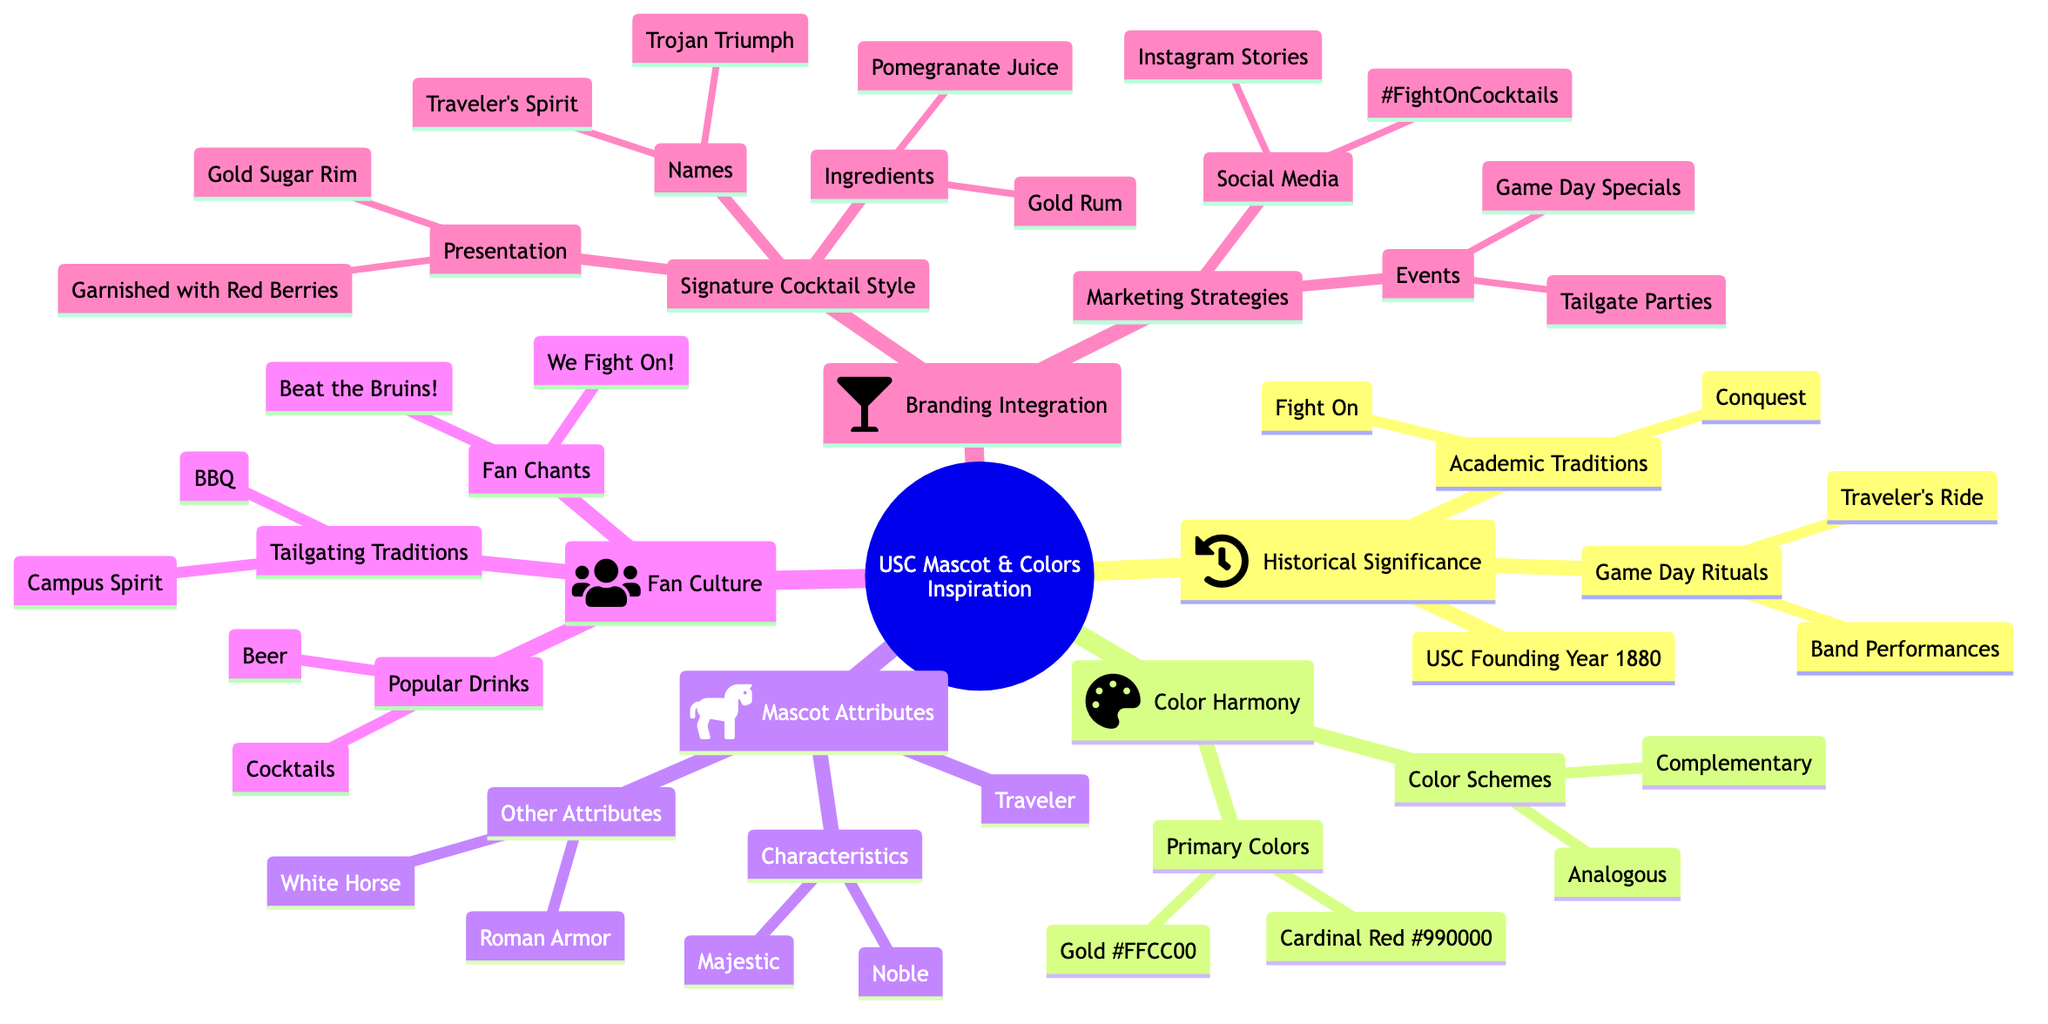What is the founding year of USC? The diagram states that the founding year of USC is 1880 under the Historical Significance section.
Answer: 1880 What are the signature cocktail names? In the Branding Integration section, the Names under Signature Cocktail Style lists "Traveler's Spirit" and "Trojan Triumph."
Answer: Traveler's Spirit, Trojan Triumph Which color is associated with the cardinal? The Color Harmony section shows that Cardinal Red is associated with the color code #990000.
Answer: Cardinal Red How many popular drinks are listed under Fan Culture? The Fan Culture section mentions two popular drinks: Beer and Cocktails. Therefore, by counting the items listed, there are two.
Answer: 2 What characteristics define Traveler? The Mascot Attributes section describes Traveler as both Majestic and Noble, highlighting two significant characteristics.
Answer: Majestic, Noble What ingredients are included in the signature cocktails? Referring to the Signature Cocktail Style under Branding Integration, the Ingredients listed are Pomegranate Juice and Gold Rum.
Answer: Pomegranate Juice, Gold Rum What type of horse is Traveler? Under the Mascot Attributes, the description states that Traveler is a White Horse, specifying the kind of horse it is.
Answer: White Horse How are the USC colors characterized in complementary schemes? In the Color Harmony section, it mentions that Cardinal Red and Green, as well as Gold and Blue, are complementary color schemes identified under Color Schemes.
Answer: Cardinal Red and Green, Gold and Blue What is a tailgating tradition listed in the diagram? The Fan Culture section outlines that BBQ is one of the Tailgating Traditions celebrated.
Answer: BBQ 